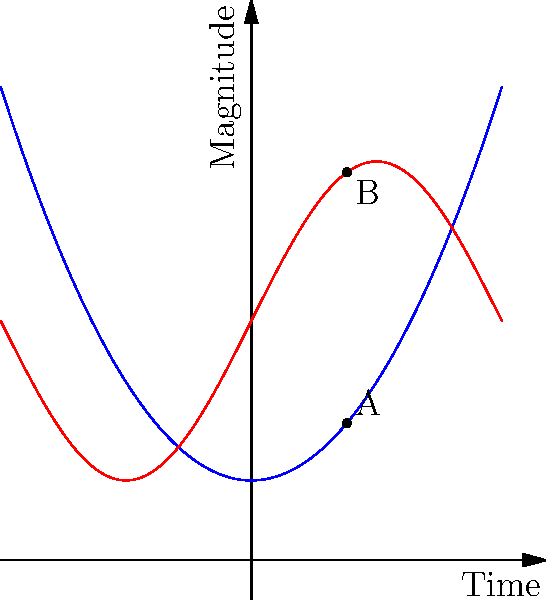In the graph above, the blue curve represents tempo and the red curve represents musical phrase intensity over time. At point A on the tempo curve, the derivative is positive, while at the corresponding time (point B) on the phrase intensity curve, the derivative is negative. How does this relationship between tempo and phrase intensity align with common practices in film scoring, and what musical effect might this create? To answer this question, we need to analyze the relationship between tempo and phrase intensity at the given points:

1. At point A on the tempo curve:
   - The curve is increasing
   - The derivative (slope) is positive
   - This indicates the tempo is accelerating

2. At point B on the phrase intensity curve:
   - The curve is decreasing
   - The derivative (slope) is negative
   - This indicates the phrase intensity is decreasing

3. Relationship analysis:
   - As tempo increases, phrase intensity decreases
   - This inverse relationship is common in film scoring

4. Musical effect:
   - Creates tension through contrast
   - Faster tempo with decreasing intensity can suggest urgency or anxiety
   - Often used in suspenseful or action scenes

5. Film scoring practice:
   - This technique is frequently employed to manipulate audience emotions
   - It can create a sense of unresolved tension or impending climax

6. Mathematical interpretation:
   - The product of the derivatives at A and B is negative
   - This negative correlation enhances the dramatic effect

7. Cinematic application:
   - Often used in chase scenes or moments of internal conflict
   - Helps to maintain engagement while controlling emotional intensity
Answer: The inverse relationship between increasing tempo and decreasing phrase intensity creates tension and is commonly used in film scoring to manipulate audience emotions, particularly in suspenseful or action scenes. 